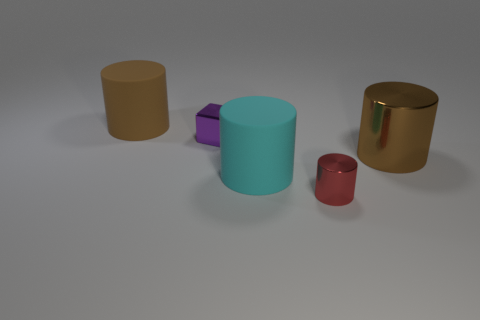Subtract all red cylinders. How many cylinders are left? 3 Add 4 small cyan metallic balls. How many objects exist? 9 Subtract all cyan cylinders. How many cylinders are left? 3 Subtract all red cubes. Subtract all purple spheres. How many cubes are left? 1 Subtract all red cubes. How many gray cylinders are left? 0 Subtract all cyan cylinders. Subtract all metal objects. How many objects are left? 1 Add 3 tiny objects. How many tiny objects are left? 5 Add 4 brown shiny things. How many brown shiny things exist? 5 Subtract 1 red cylinders. How many objects are left? 4 Subtract all cylinders. How many objects are left? 1 